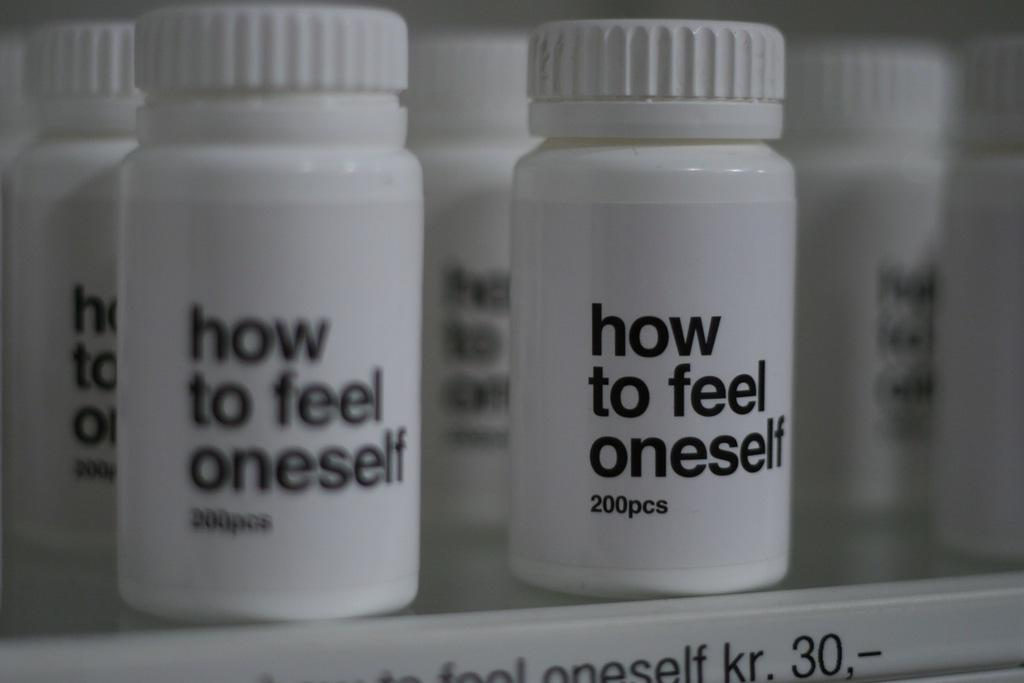<image>
Provide a brief description of the given image. A pill bottle contains 200pcs of how to feel oneself. 